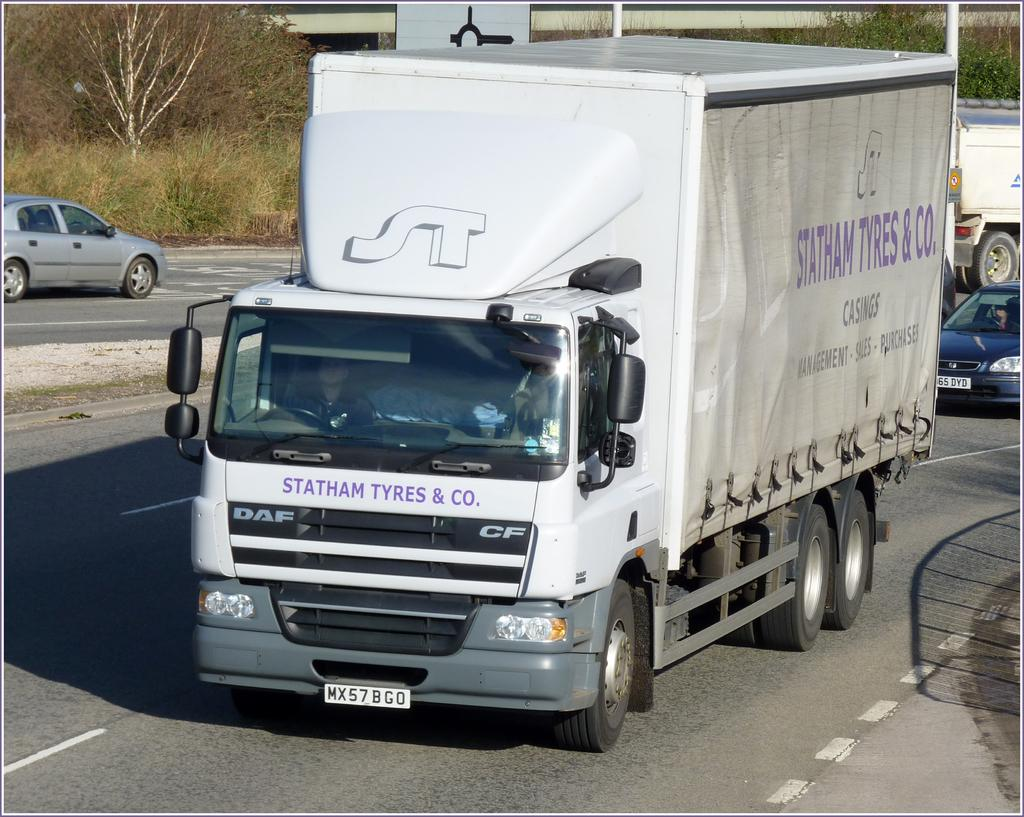What is present on the road in the image? There are vehicles on the road in the image. What can be seen behind the vehicles in the image? There are trees behind the vehicles in the image. What structures are visible in the image? There are poles visible in the image. What type of bone can be seen in the image? There is no bone present in the image. How many parks are visible in the image? There is no park present in the image. 